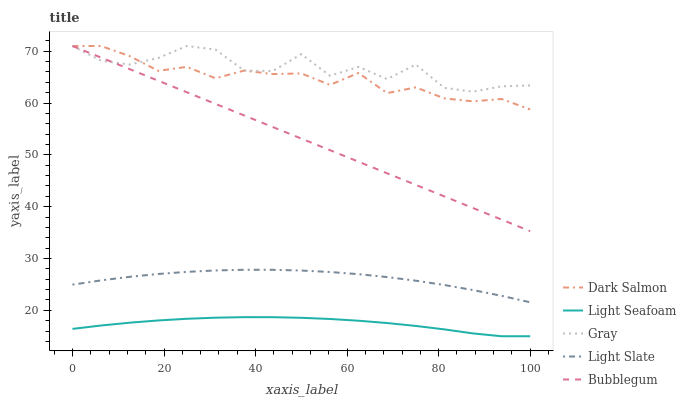Does Light Seafoam have the minimum area under the curve?
Answer yes or no. Yes. Does Gray have the maximum area under the curve?
Answer yes or no. Yes. Does Gray have the minimum area under the curve?
Answer yes or no. No. Does Light Seafoam have the maximum area under the curve?
Answer yes or no. No. Is Bubblegum the smoothest?
Answer yes or no. Yes. Is Gray the roughest?
Answer yes or no. Yes. Is Light Seafoam the smoothest?
Answer yes or no. No. Is Light Seafoam the roughest?
Answer yes or no. No. Does Light Seafoam have the lowest value?
Answer yes or no. Yes. Does Gray have the lowest value?
Answer yes or no. No. Does Bubblegum have the highest value?
Answer yes or no. Yes. Does Light Seafoam have the highest value?
Answer yes or no. No. Is Light Seafoam less than Gray?
Answer yes or no. Yes. Is Dark Salmon greater than Light Slate?
Answer yes or no. Yes. Does Gray intersect Bubblegum?
Answer yes or no. Yes. Is Gray less than Bubblegum?
Answer yes or no. No. Is Gray greater than Bubblegum?
Answer yes or no. No. Does Light Seafoam intersect Gray?
Answer yes or no. No. 